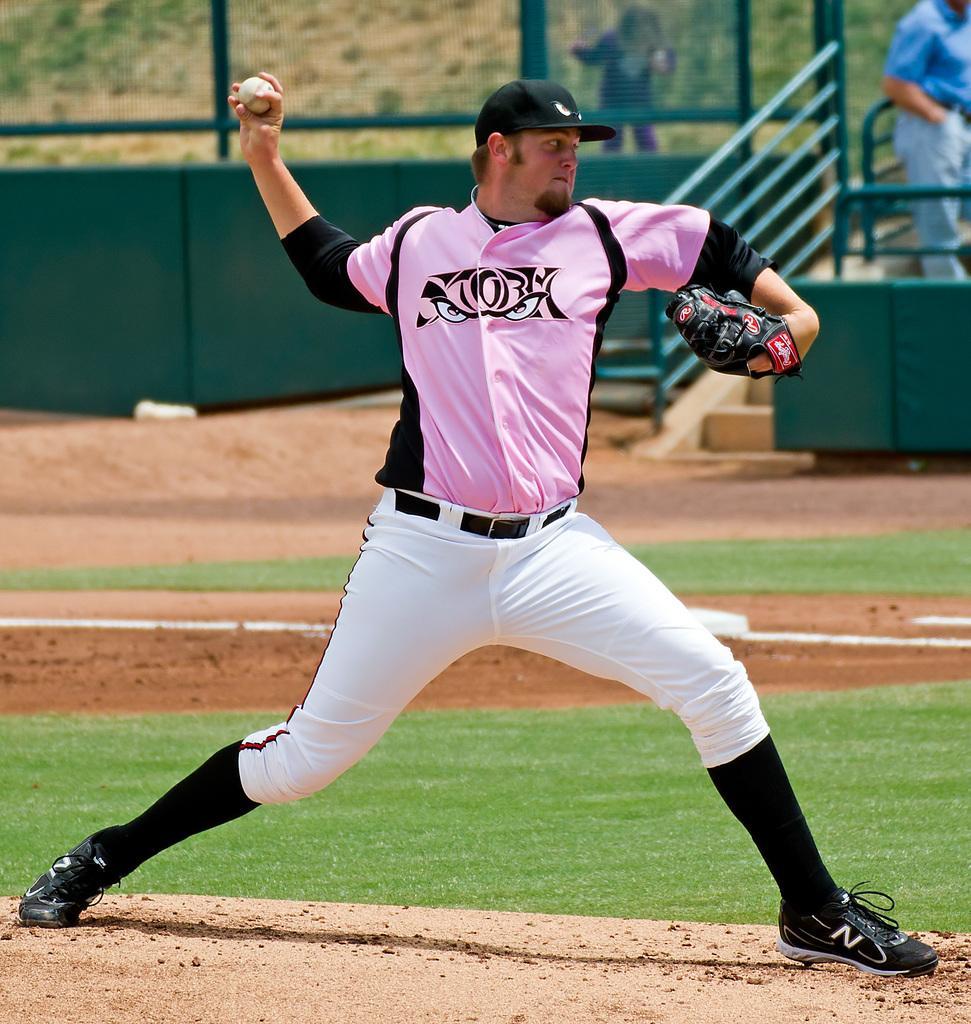Can you describe this image briefly? In this image we can see a player holding the ball and also wearing the cap and gloves. We can also see the grassland, stairs and also the green color fence. In the background we can see two persons. 